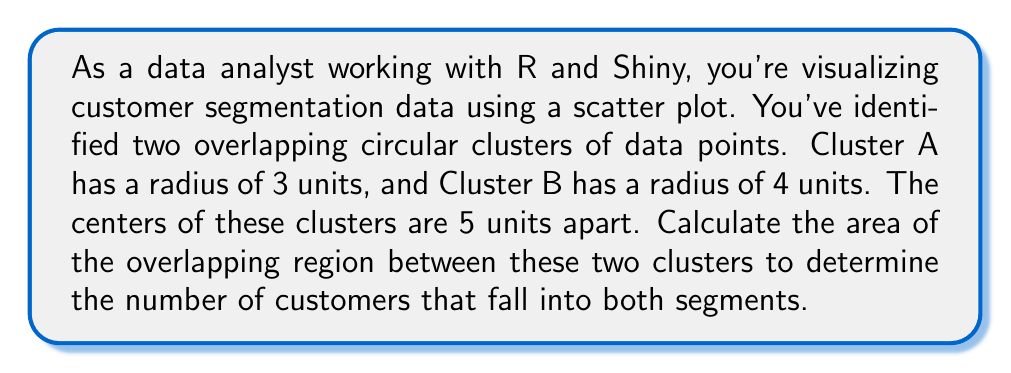What is the answer to this math problem? To solve this problem, we need to calculate the area of the overlapping region between two circles. This can be done using the following steps:

1. Identify the radii of the circles:
   $r_1 = 3$ (Cluster A)
   $r_2 = 4$ (Cluster B)

2. Identify the distance between the centers:
   $d = 5$

3. Calculate the area of overlap using the formula for the area of intersection of two circles:

   $$A = r_1^2 \arccos\left(\frac{d^2 + r_1^2 - r_2^2}{2dr_1}\right) + r_2^2 \arccos\left(\frac{d^2 + r_2^2 - r_1^2}{2dr_2}\right) - \frac{1}{2}\sqrt{(-d+r_1+r_2)(d+r_1-r_2)(d-r_1+r_2)(d+r_1+r_2)}$$

4. Substitute the values:

   $$A = 3^2 \arccos\left(\frac{5^2 + 3^2 - 4^2}{2 \cdot 5 \cdot 3}\right) + 4^2 \arccos\left(\frac{5^2 + 4^2 - 3^2}{2 \cdot 5 \cdot 4}\right) - \frac{1}{2}\sqrt{(-5+3+4)(5+3-4)(5-3+4)(5+3+4)}$$

5. Simplify and calculate:

   $$A = 9 \arccos\left(\frac{34}{30}\right) + 16 \arccos\left(\frac{41}{40}\right) - \frac{1}{2}\sqrt{2 \cdot 4 \cdot 6 \cdot 12}$$
   $$A \approx 9 \cdot 0.4636 + 16 \cdot 0.2526 - \frac{1}{2}\sqrt{576}$$
   $$A \approx 4.1724 + 4.0416 - 12$$
   $$A \approx 8.2140 - 12$$
   $$A \approx 8.2140$$

The area of the overlapping region is approximately 8.2140 square units.
Answer: The area of the overlapping region between the two clusters is approximately 8.2140 square units. 